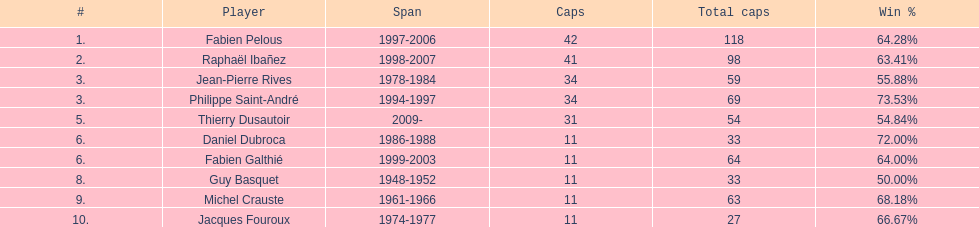What is the combined cap count for jean-pierre rives and michel crauste? 122. 